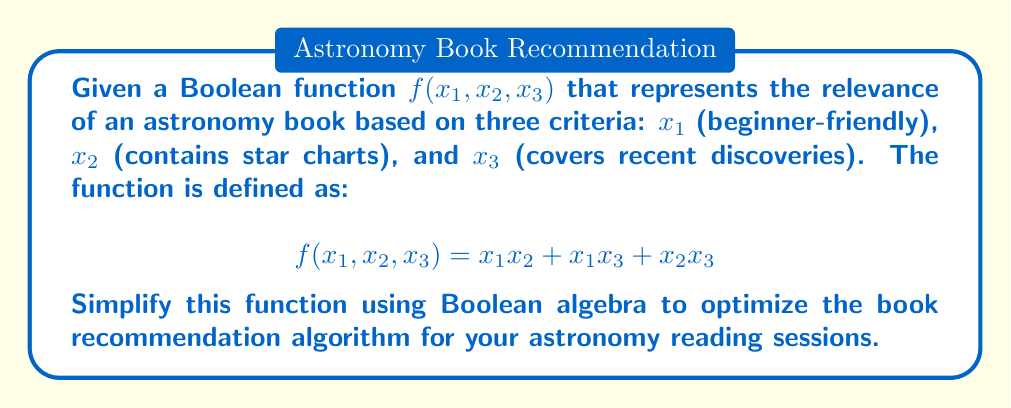Show me your answer to this math problem. Let's simplify the function $f(x_1, x_2, x_3) = x_1x_2 + x_1x_3 + x_2x_3$ step by step:

1) First, we can factor out $x_1$ from the first two terms:
   $$f(x_1, x_2, x_3) = x_1(x_2 + x_3) + x_2x_3$$

2) Now, we can apply the absorption law to simplify further. The absorption law states that $A + AB = A$ for any Boolean variables $A$ and $B$. In our case, let $A = x_1(x_2 + x_3)$ and $B = x_2x_3$:

   $$\begin{align}
   f(x_1, x_2, x_3) &= x_1(x_2 + x_3) + x_2x_3 \\
   &= x_1(x_2 + x_3) + x_2x_3(x_1 + 1) \quad \text{(adding $x_1$ doesn't change $x_2x_3$)} \\
   &= x_1(x_2 + x_3) + x_1x_2x_3 + x_2x_3
   \end{align}$$

3) Now we can factor out $(x_2 + x_3)$:

   $$f(x_1, x_2, x_3) = (x_2 + x_3)(x_1 + 1)$$

4) In Boolean algebra, $(x_1 + 1) = 1$ for any $x_1$, so our final simplified function is:

   $$f(x_1, x_2, x_3) = x_2 + x_3$$

This simplified function means that a book is recommended if it either contains star charts ($x_2$) or covers recent discoveries ($x_3$), regardless of whether it's beginner-friendly ($x_1$).
Answer: $x_2 + x_3$ 